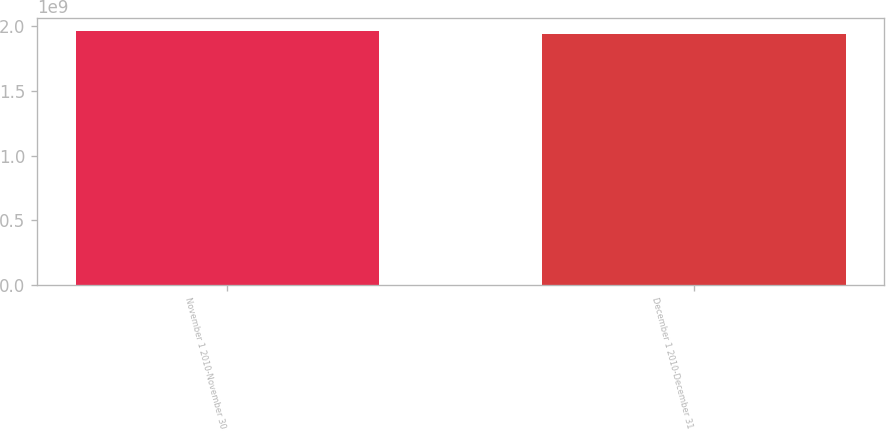<chart> <loc_0><loc_0><loc_500><loc_500><bar_chart><fcel>November 1 2010-November 30<fcel>December 1 2010-December 31<nl><fcel>1.96741e+09<fcel>1.94371e+09<nl></chart> 